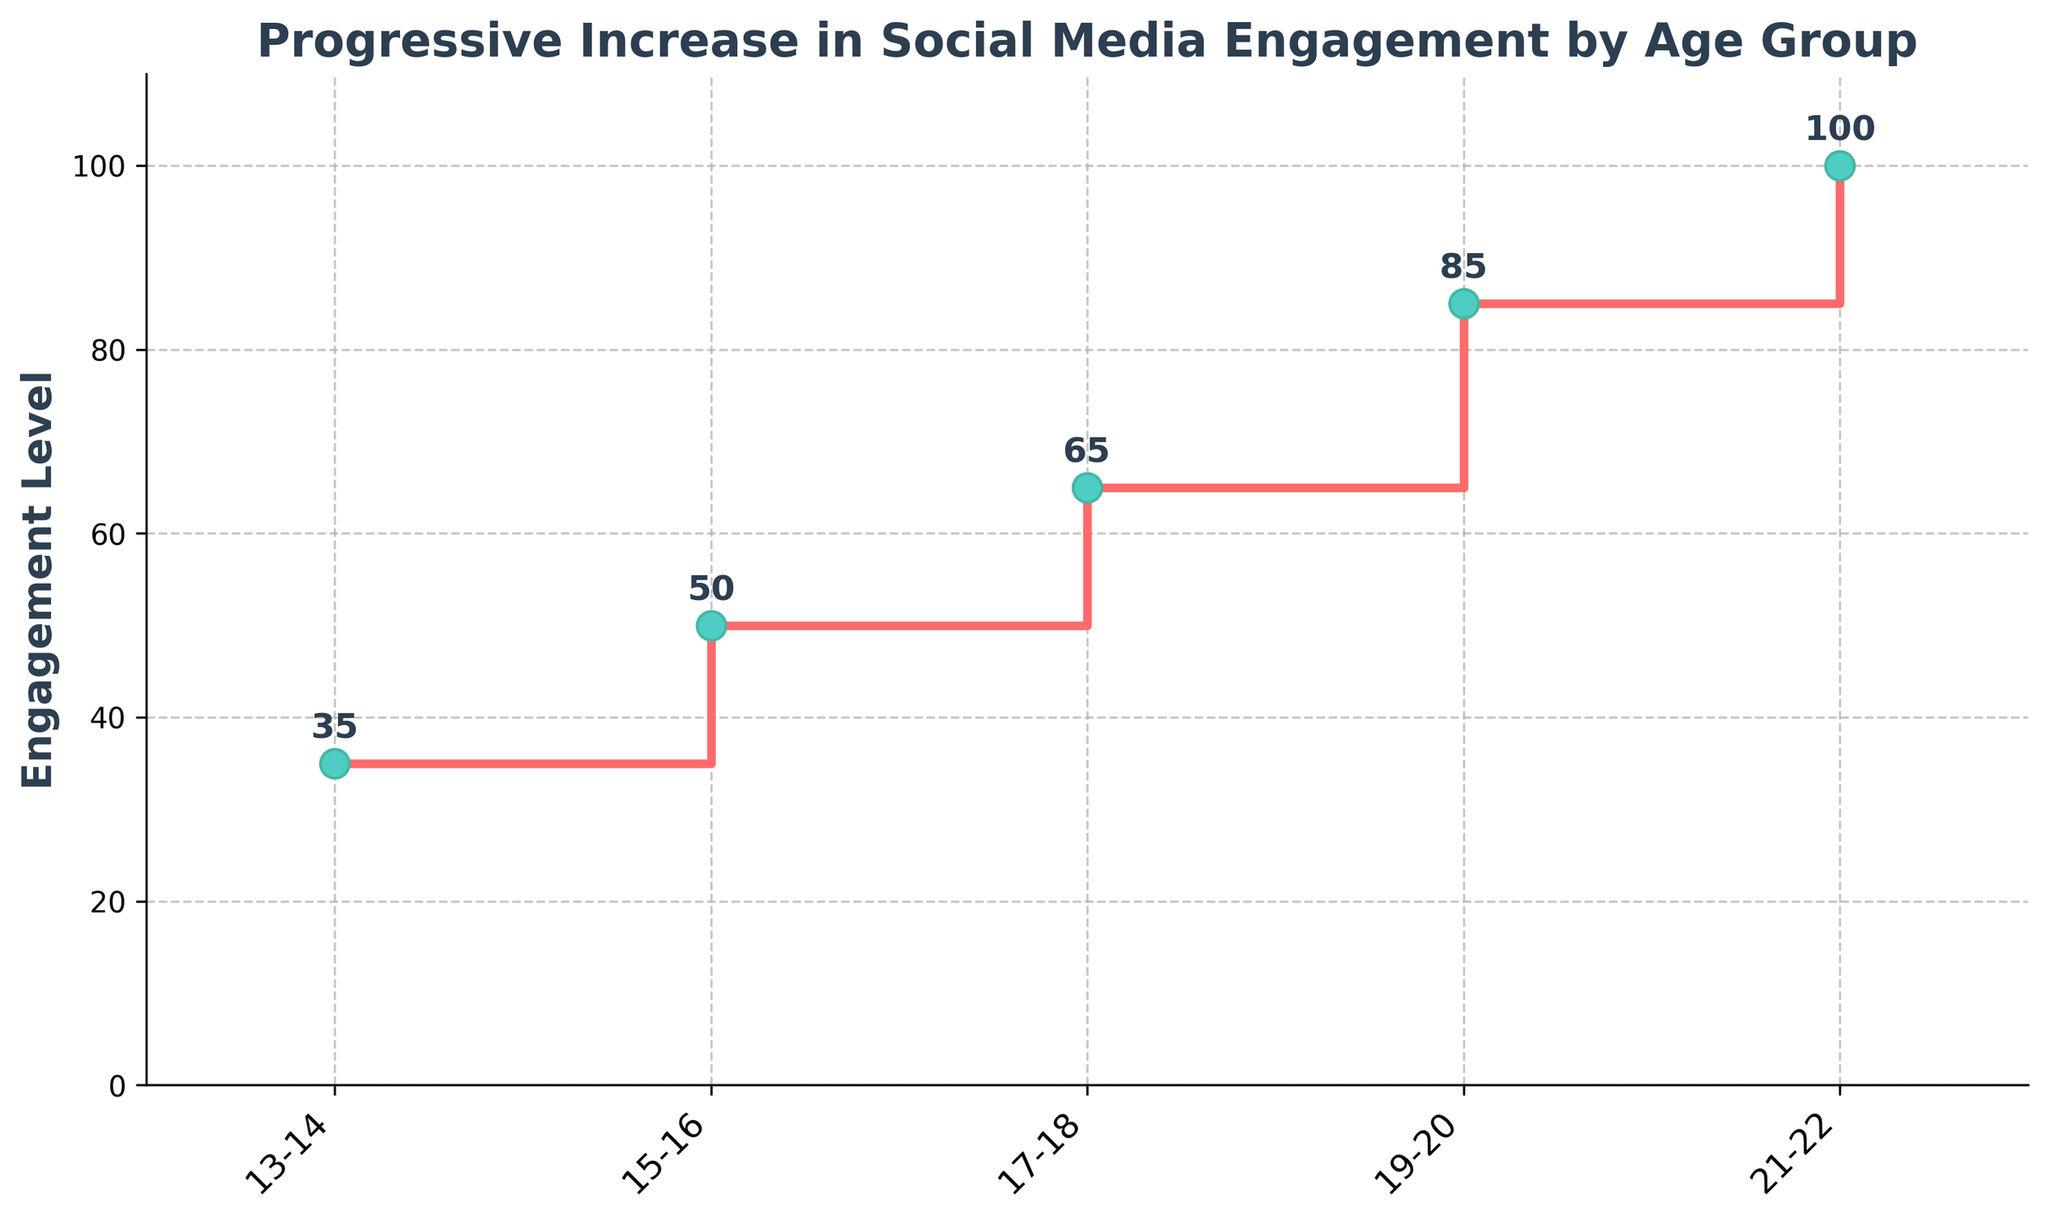What is the title of the stair plot? The title is prominently displayed at the top of the figure. It gives the viewer the context of what the plot represents. According to the data provided, the title should indicate the trend of social media engagement across various age groups.
Answer: Progressive Increase in Social Media Engagement by Age Group What is the engagement level for the 17-18 age group? To find the engagement level for a specific age group, locate the corresponding tick on the x-axis and read the height of the step above it. For the 17-18 age group, the height of the step is 65.
Answer: 65 How does the engagement level change from the 15-16 age group to the 19-20 age group? To answer this comparison, subtract the engagement level of the 15-16 age group from the 19-20 age group. From the graph, the engagement levels are 50 for 15-16 and 85 for 19-20. So, 85 - 50 = 35.
Answer: 35 Which age group has the highest engagement level? To find the age group with the highest engagement level, identify the tallest step on the graph. The highest step comes at the end of the x-axis which is for the 21-22 age group with an engagement level of 100.
Answer: 21-22 On average, how much does the engagement level increase between consecutive age groups? Calculate the total change in engagement level and divide it by the number of intervals (gaps) between age groups. First, sum the increments: (50-35) + (65-50) + (85-65) + (100-85) = 15 + 15 + 20 + 15 = 65. There are 4 intervals, so the average increase is 65/4 = 16.25.
Answer: 16.25 What color is used for the markers representing each data point? The plot uses a specific color for the markers to distinguish the data points. According to the provided code, the marker color is described as turquoise, which is specified as '#4ECDC4'.
Answer: Turquoise (or #4ECDC4) Is there a group where the engagement level doubles compared to the 13-14 age group? Check if any subsequent age group's engagement level is exactly double that of the 13-14 age group, which has an engagement level of 35. Doubling 35 gives 70. Compare this to the other engagement levels: 50, 65, 85, 100—none of these match 70.
Answer: No What is the difference in engagement levels between the youngest and oldest age groups represented? Subtract the engagement level of the youngest age group (13-14) from the oldest age group (21-22). The values are 100 for 21-22 and 35 for 13-14, so 100 - 35 = 65.
Answer: 65 What kind of trend do you observe in the plot? Observing the overall pattern of the steps, you see that engagement levels increase progressively without any decrease, indicating a consistently upward trend as age increases.
Answer: Upward trend 